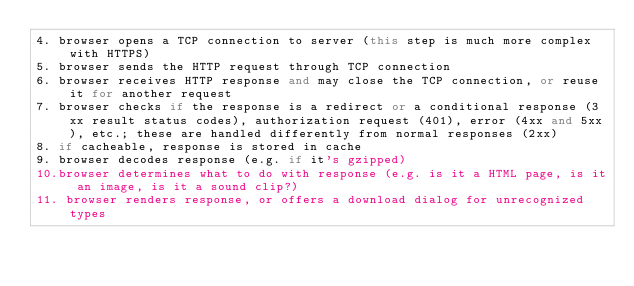Convert code to text. <code><loc_0><loc_0><loc_500><loc_500><_C++_>4. browser opens a TCP connection to server (this step is much more complex with HTTPS)
5. browser sends the HTTP request through TCP connection
6. browser receives HTTP response and may close the TCP connection, or reuse it for another request
7. browser checks if the response is a redirect or a conditional response (3xx result status codes), authorization request (401), error (4xx and 5xx), etc.; these are handled differently from normal responses (2xx)
8. if cacheable, response is stored in cache
9. browser decodes response (e.g. if it's gzipped)
10.browser determines what to do with response (e.g. is it a HTML page, is it an image, is it a sound clip?)
11. browser renders response, or offers a download dialog for unrecognized types
</code> 